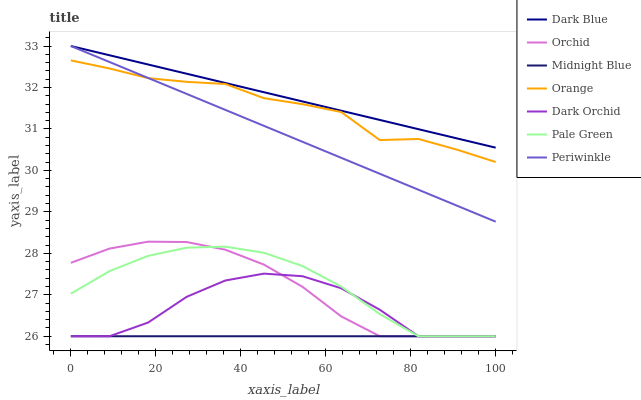Does Midnight Blue have the minimum area under the curve?
Answer yes or no. Yes. Does Dark Blue have the maximum area under the curve?
Answer yes or no. Yes. Does Dark Orchid have the minimum area under the curve?
Answer yes or no. No. Does Dark Orchid have the maximum area under the curve?
Answer yes or no. No. Is Midnight Blue the smoothest?
Answer yes or no. Yes. Is Dark Orchid the roughest?
Answer yes or no. Yes. Is Dark Blue the smoothest?
Answer yes or no. No. Is Dark Blue the roughest?
Answer yes or no. No. Does Midnight Blue have the lowest value?
Answer yes or no. Yes. Does Dark Blue have the lowest value?
Answer yes or no. No. Does Periwinkle have the highest value?
Answer yes or no. Yes. Does Dark Orchid have the highest value?
Answer yes or no. No. Is Orchid less than Dark Blue?
Answer yes or no. Yes. Is Orange greater than Midnight Blue?
Answer yes or no. Yes. Does Midnight Blue intersect Dark Orchid?
Answer yes or no. Yes. Is Midnight Blue less than Dark Orchid?
Answer yes or no. No. Is Midnight Blue greater than Dark Orchid?
Answer yes or no. No. Does Orchid intersect Dark Blue?
Answer yes or no. No. 